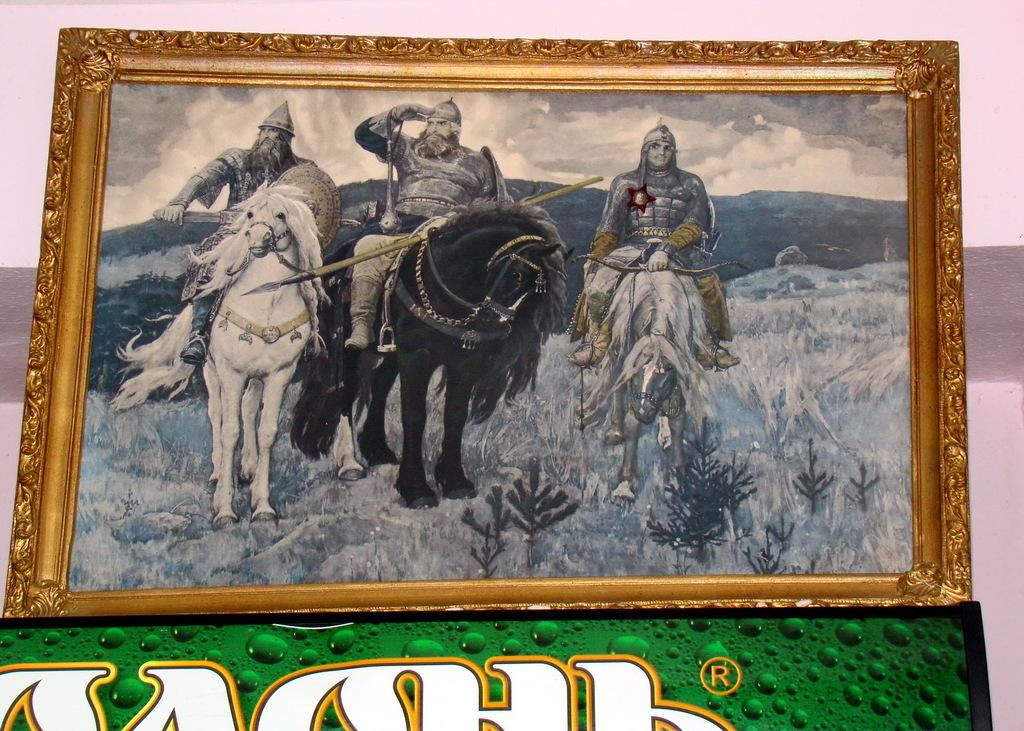What object is present in the image that contains a visual representation? There is a picture frame in the image. What is depicted within the picture frame? The picture frame contains three persons. What are the persons in the picture frame doing? The persons are sitting on horses. Can you describe the behavior of the middle person in the picture frame? The middle person is shouting. What additional information is provided below the picture frame? There is text written below the picture frame. How many babies are playing with sand in the image? There are no babies or sand present in the image. 